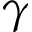Convert formula to latex. <formula><loc_0><loc_0><loc_500><loc_500>\gamma</formula> 